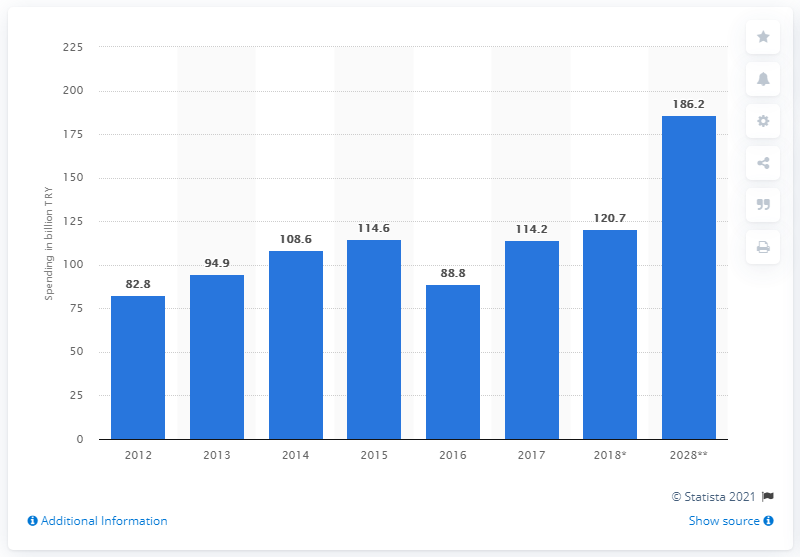Indicate a few pertinent items in this graphic. In 2017, visitors to Turkey spent a total of 114.6 billion Turkish lira. 